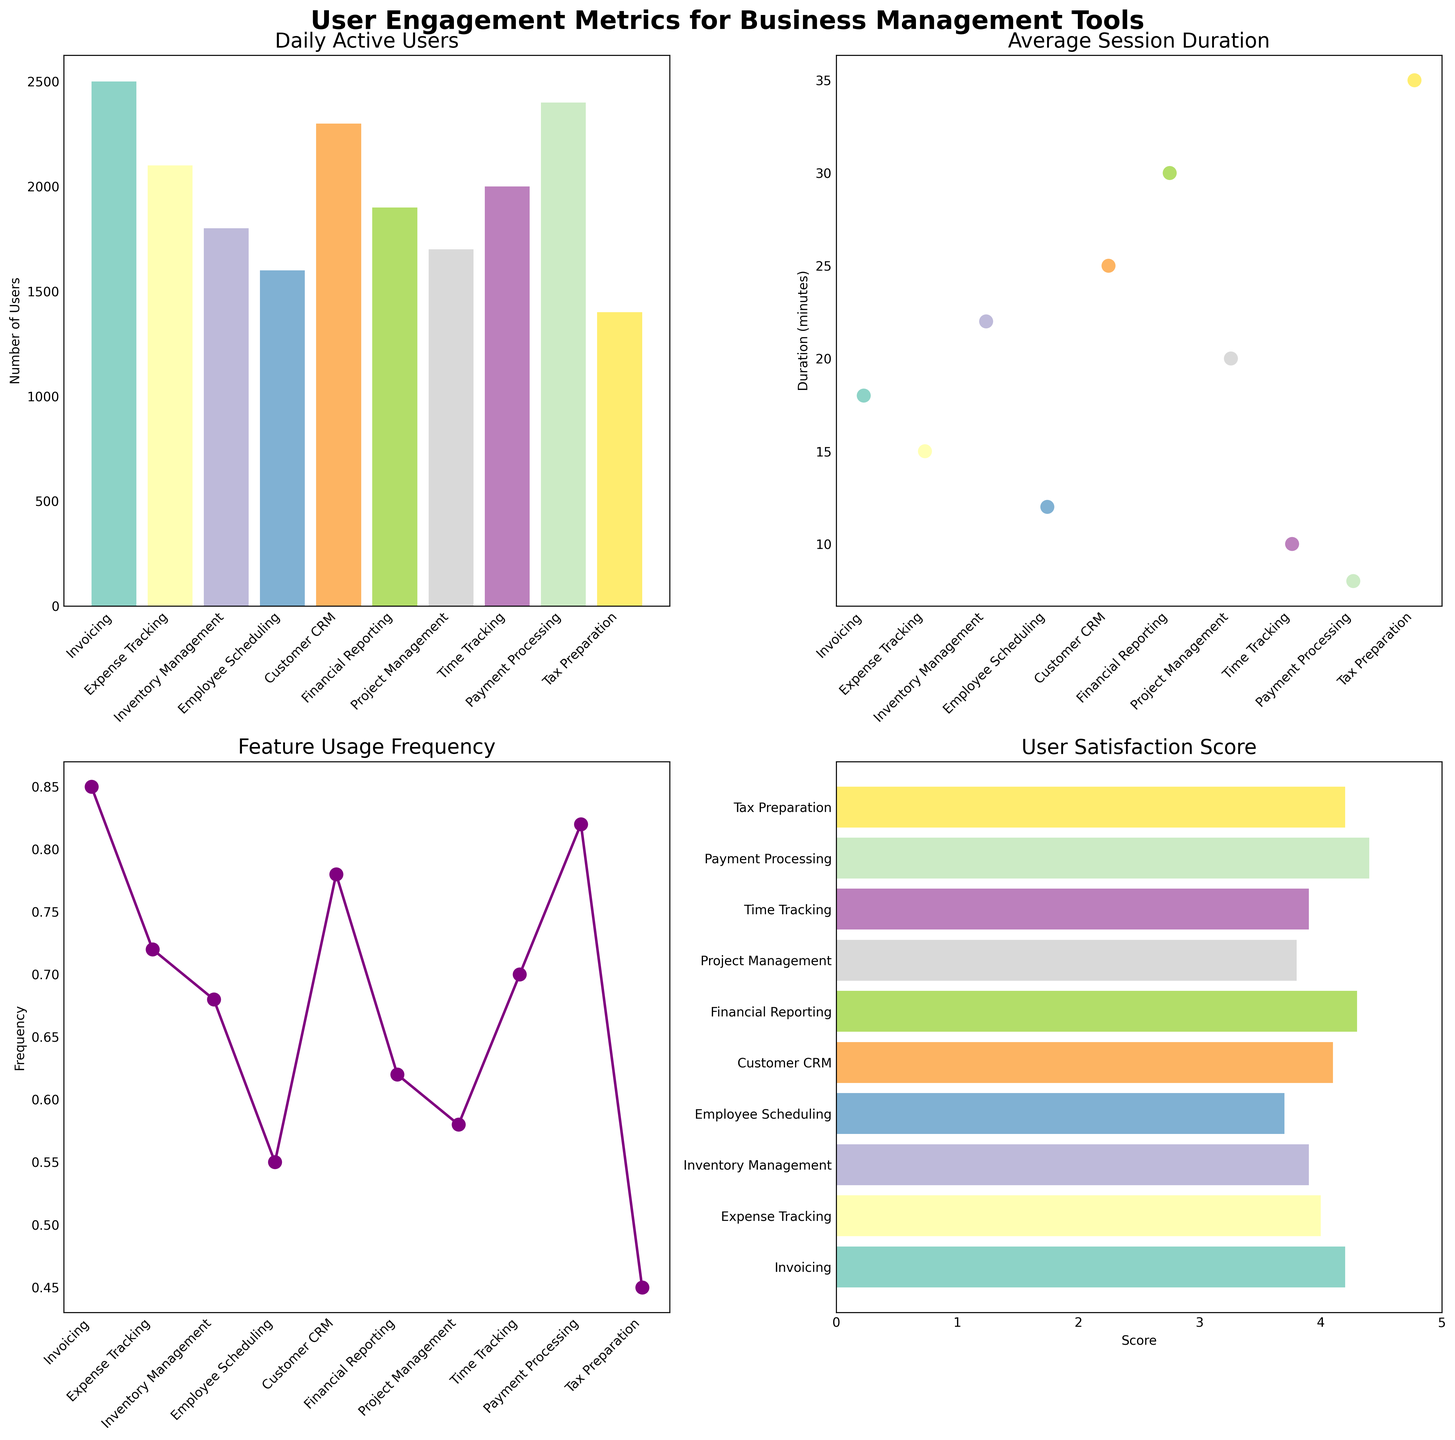What feature has the highest number of Daily Active Users? To determine this, look at the first subplot showing Daily Active Users. The tallest bar represents the feature with the highest number of users. Identify the feature name corresponding to this bar.
Answer: Invoicing Which feature has the lowest User Satisfaction Score? Look at the fourth subplot depicting User Satisfaction Scores. Find the shortest horizontal bar, which indicates the feature with the lowest score. Identify the feature name corresponding to this bar.
Answer: Employee Scheduling What is the total of feature usage frequencies across all features? Add up the values from the Feature Usage Frequency subplot (third subplot) for each feature. Sum the values 0.85, 0.72, 0.68, 0.55, 0.78, 0.62, 0.58, 0.70, 0.82, 0.45. The total is calculated as 0.85 + 0.72 + 0.68 + 0.55 + 0.78 + 0.62 + 0.58 + 0.70 + 0.82 + 0.45 = 6.75.
Answer: 6.75 Which features have a User Satisfaction Score greater than 4.0? Refer to the fourth subplot showing User Satisfaction Scores. Identify the horizontal bars that extend beyond the 4.0 mark on the x-axis. The features corresponding to these bars are the ones with scores greater than 4.0.
Answer: Invoicing, Financial Reporting, Payment Processing, Tax Preparation Is the feature with the highest Average Session Duration also among the highest in User Satisfaction Score? Find the feature with the highest Average Session Duration in the second subplot (Tax Preparation with 35 minutes). Then, check the User Satisfaction Score subplot to see if Tax Preparation has one of the highest scores, which it does as it has a score of 4.2.
Answer: Yes Compare the Daily Active Users between Customer CRM and Project Management. Which one has more active users, and by how much? Look at the first subplot for Daily Active Users. Compare the bar heights of Customer CRM and Project Management. Customer CRM has 2300 users, and Project Management has 1700 users. Subtract the latter from the former: 2300 - 1700 = 600.
Answer: Customer CRM by 600 What is the average session duration for features with more than 2000 Daily Active Users? Identify features with more than 2000 Daily Active Users from the first subplot (Invoicing, Customer CRM, and Payment Processing). Their Average Session Durations in the second subplot are 18, 25, and 8 minutes, respectively. Calculate the average: (18 + 25 + 8) / 3 = 51 / 3 = 17.
Answer: 17 minutes Which feature has the largest difference between Daily Active Users and User Satisfaction Score? Analyze the differences by subtracting the User Satisfaction Scores from the Daily Active Users for each feature. The highest difference appears when subtracting the User Satisfaction Score (normalized to 2500 for fairness) from the Daily Active Users in the Invoicing feature: 2500 (Daily Active Users) - 4.2 (User Satisfaction Score * 600 approx.) = 2260.
Answer: Invoicing 